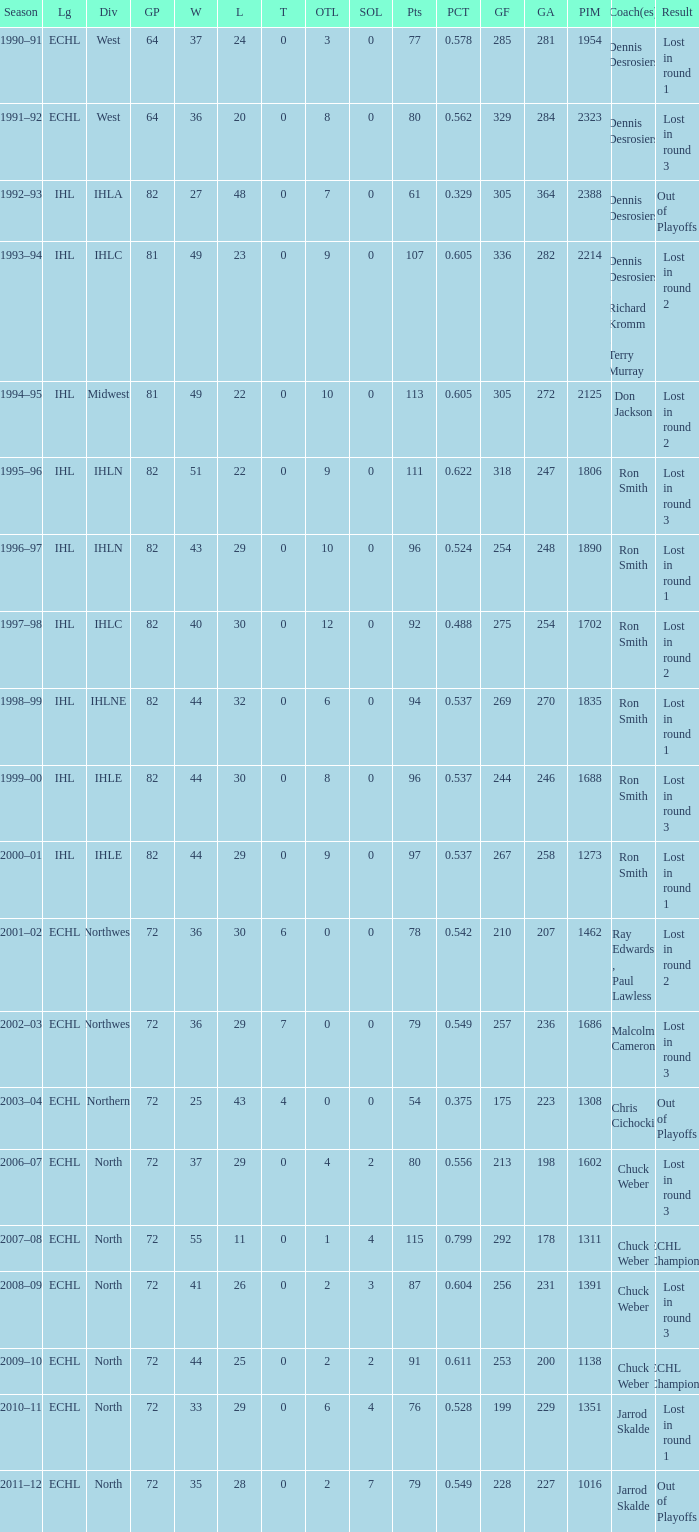What was the maximum OTL if L is 28? 2.0. 